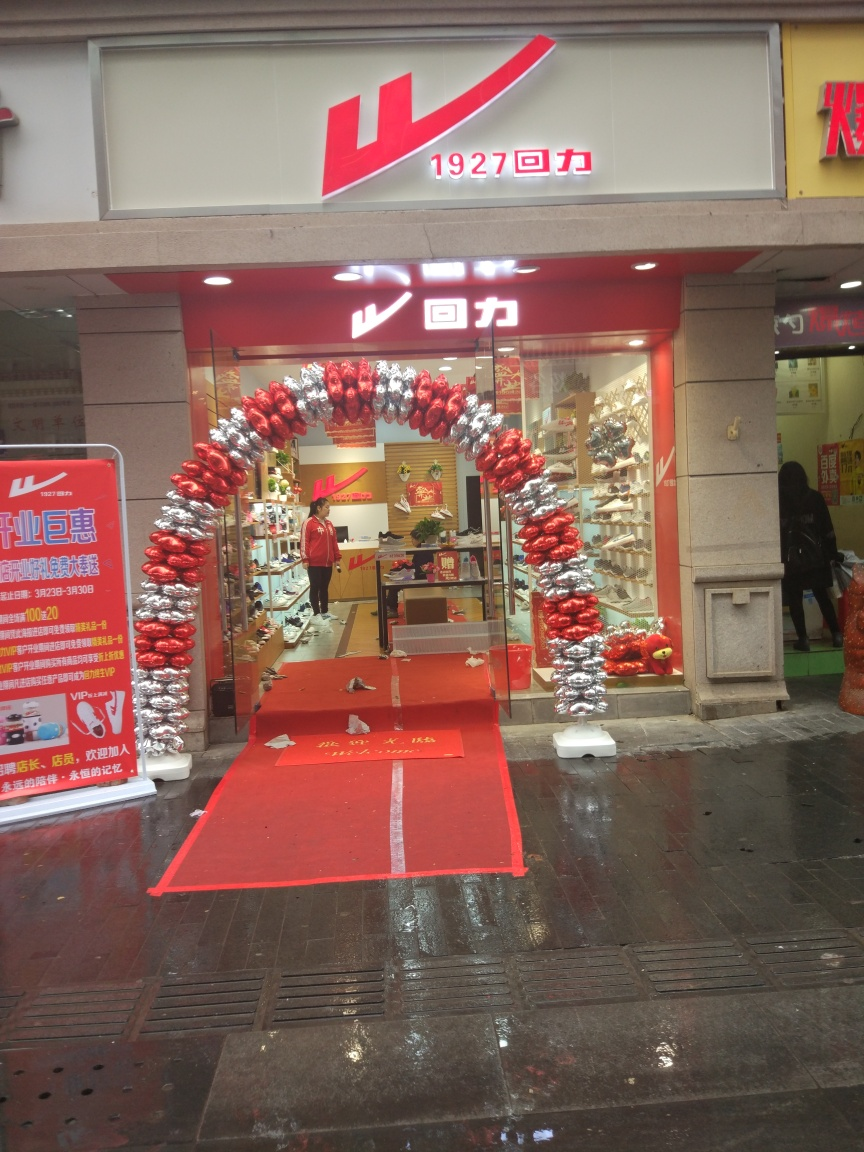Is there any signage or branding that indicates where this photo might have been taken? The signage above the store displays a distinctive red logo and includes Chinese characters, which implies that the photo was likely taken in a Chinese-speaking region. 